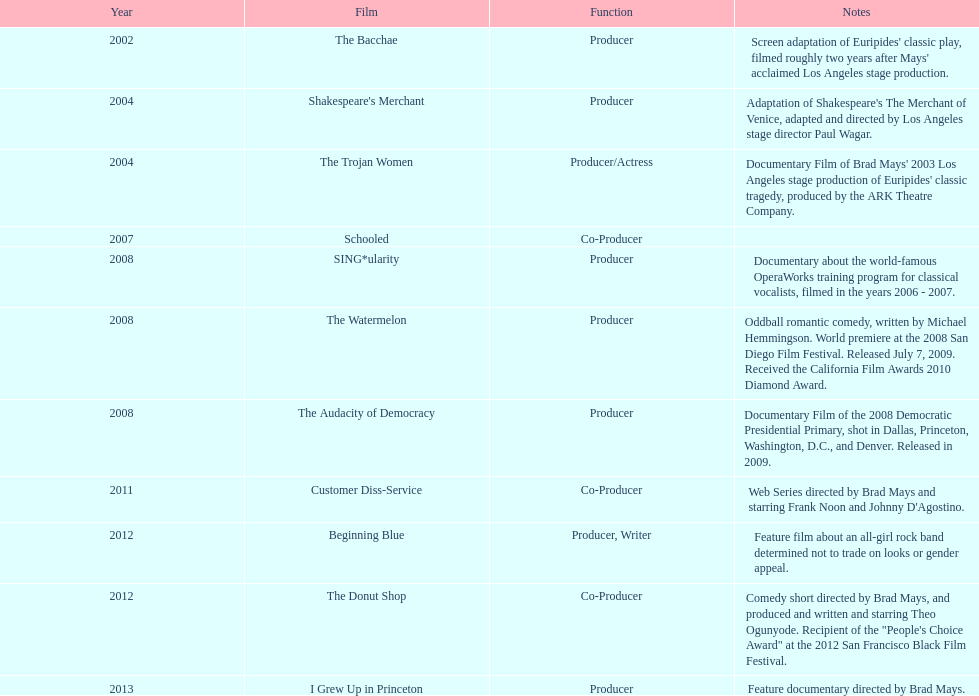Would you be able to parse every entry in this table? {'header': ['Year', 'Film', 'Function', 'Notes'], 'rows': [['2002', 'The Bacchae', 'Producer', "Screen adaptation of Euripides' classic play, filmed roughly two years after Mays' acclaimed Los Angeles stage production."], ['2004', "Shakespeare's Merchant", 'Producer', "Adaptation of Shakespeare's The Merchant of Venice, adapted and directed by Los Angeles stage director Paul Wagar."], ['2004', 'The Trojan Women', 'Producer/Actress', "Documentary Film of Brad Mays' 2003 Los Angeles stage production of Euripides' classic tragedy, produced by the ARK Theatre Company."], ['2007', 'Schooled', 'Co-Producer', ''], ['2008', 'SING*ularity', 'Producer', 'Documentary about the world-famous OperaWorks training program for classical vocalists, filmed in the years 2006 - 2007.'], ['2008', 'The Watermelon', 'Producer', 'Oddball romantic comedy, written by Michael Hemmingson. World premiere at the 2008 San Diego Film Festival. Released July 7, 2009. Received the California Film Awards 2010 Diamond Award.'], ['2008', 'The Audacity of Democracy', 'Producer', 'Documentary Film of the 2008 Democratic Presidential Primary, shot in Dallas, Princeton, Washington, D.C., and Denver. Released in 2009.'], ['2011', 'Customer Diss-Service', 'Co-Producer', "Web Series directed by Brad Mays and starring Frank Noon and Johnny D'Agostino."], ['2012', 'Beginning Blue', 'Producer, Writer', 'Feature film about an all-girl rock band determined not to trade on looks or gender appeal.'], ['2012', 'The Donut Shop', 'Co-Producer', 'Comedy short directed by Brad Mays, and produced and written and starring Theo Ogunyode. Recipient of the "People\'s Choice Award" at the 2012 San Francisco Black Film Festival.'], ['2013', 'I Grew Up in Princeton', 'Producer', 'Feature documentary directed by Brad Mays.']]} What documentary film was produced before the year 2011 but after 2008? The Audacity of Democracy. 